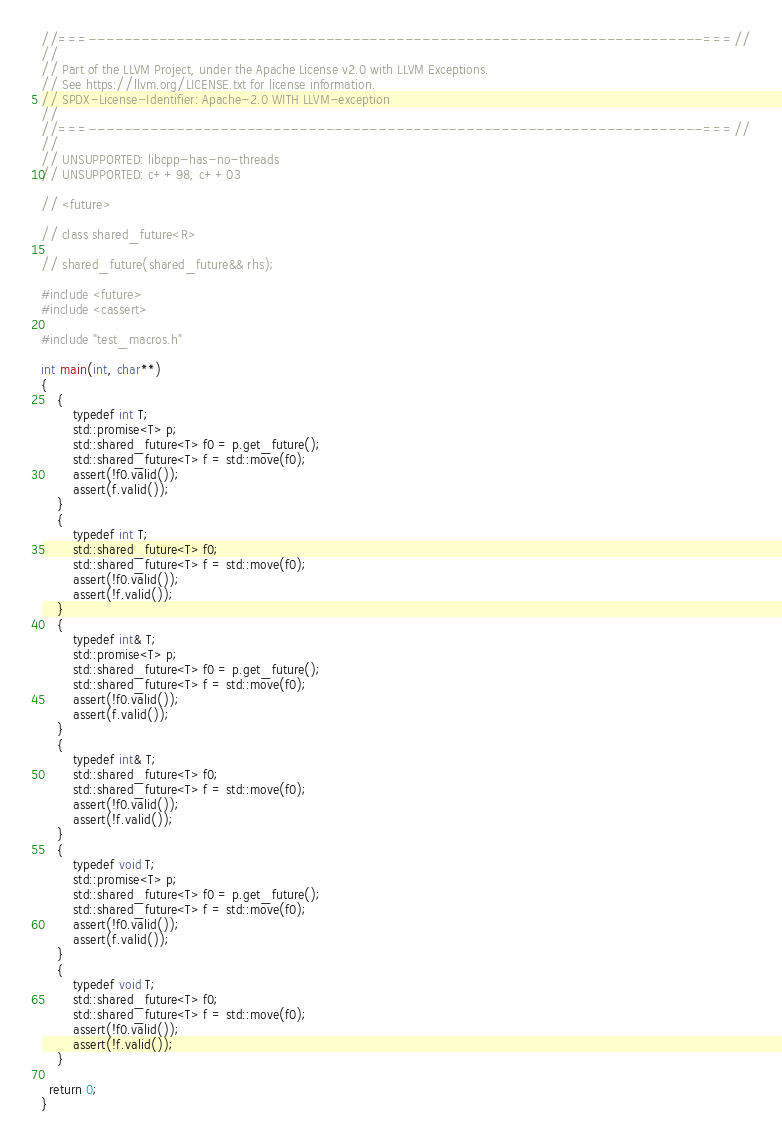<code> <loc_0><loc_0><loc_500><loc_500><_C++_>//===----------------------------------------------------------------------===//
//
// Part of the LLVM Project, under the Apache License v2.0 with LLVM Exceptions.
// See https://llvm.org/LICENSE.txt for license information.
// SPDX-License-Identifier: Apache-2.0 WITH LLVM-exception
//
//===----------------------------------------------------------------------===//
//
// UNSUPPORTED: libcpp-has-no-threads
// UNSUPPORTED: c++98, c++03

// <future>

// class shared_future<R>

// shared_future(shared_future&& rhs);

#include <future>
#include <cassert>

#include "test_macros.h"

int main(int, char**)
{
    {
        typedef int T;
        std::promise<T> p;
        std::shared_future<T> f0 = p.get_future();
        std::shared_future<T> f = std::move(f0);
        assert(!f0.valid());
        assert(f.valid());
    }
    {
        typedef int T;
        std::shared_future<T> f0;
        std::shared_future<T> f = std::move(f0);
        assert(!f0.valid());
        assert(!f.valid());
    }
    {
        typedef int& T;
        std::promise<T> p;
        std::shared_future<T> f0 = p.get_future();
        std::shared_future<T> f = std::move(f0);
        assert(!f0.valid());
        assert(f.valid());
    }
    {
        typedef int& T;
        std::shared_future<T> f0;
        std::shared_future<T> f = std::move(f0);
        assert(!f0.valid());
        assert(!f.valid());
    }
    {
        typedef void T;
        std::promise<T> p;
        std::shared_future<T> f0 = p.get_future();
        std::shared_future<T> f = std::move(f0);
        assert(!f0.valid());
        assert(f.valid());
    }
    {
        typedef void T;
        std::shared_future<T> f0;
        std::shared_future<T> f = std::move(f0);
        assert(!f0.valid());
        assert(!f.valid());
    }

  return 0;
}
</code> 